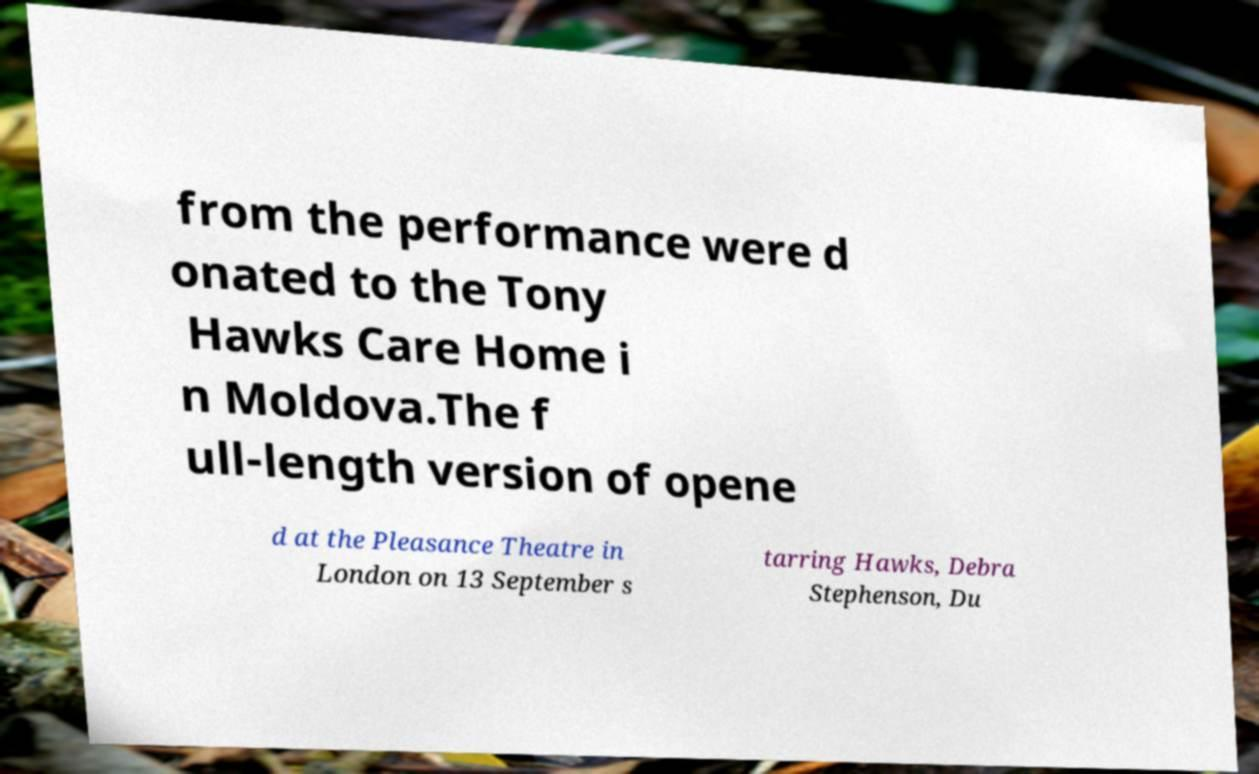Please identify and transcribe the text found in this image. from the performance were d onated to the Tony Hawks Care Home i n Moldova.The f ull-length version of opene d at the Pleasance Theatre in London on 13 September s tarring Hawks, Debra Stephenson, Du 